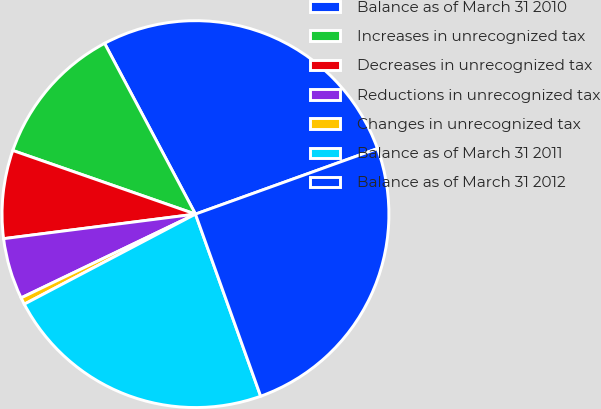<chart> <loc_0><loc_0><loc_500><loc_500><pie_chart><fcel>Balance as of March 31 2010<fcel>Increases in unrecognized tax<fcel>Decreases in unrecognized tax<fcel>Reductions in unrecognized tax<fcel>Changes in unrecognized tax<fcel>Balance as of March 31 2011<fcel>Balance as of March 31 2012<nl><fcel>27.28%<fcel>11.88%<fcel>7.36%<fcel>5.1%<fcel>0.58%<fcel>22.76%<fcel>25.02%<nl></chart> 